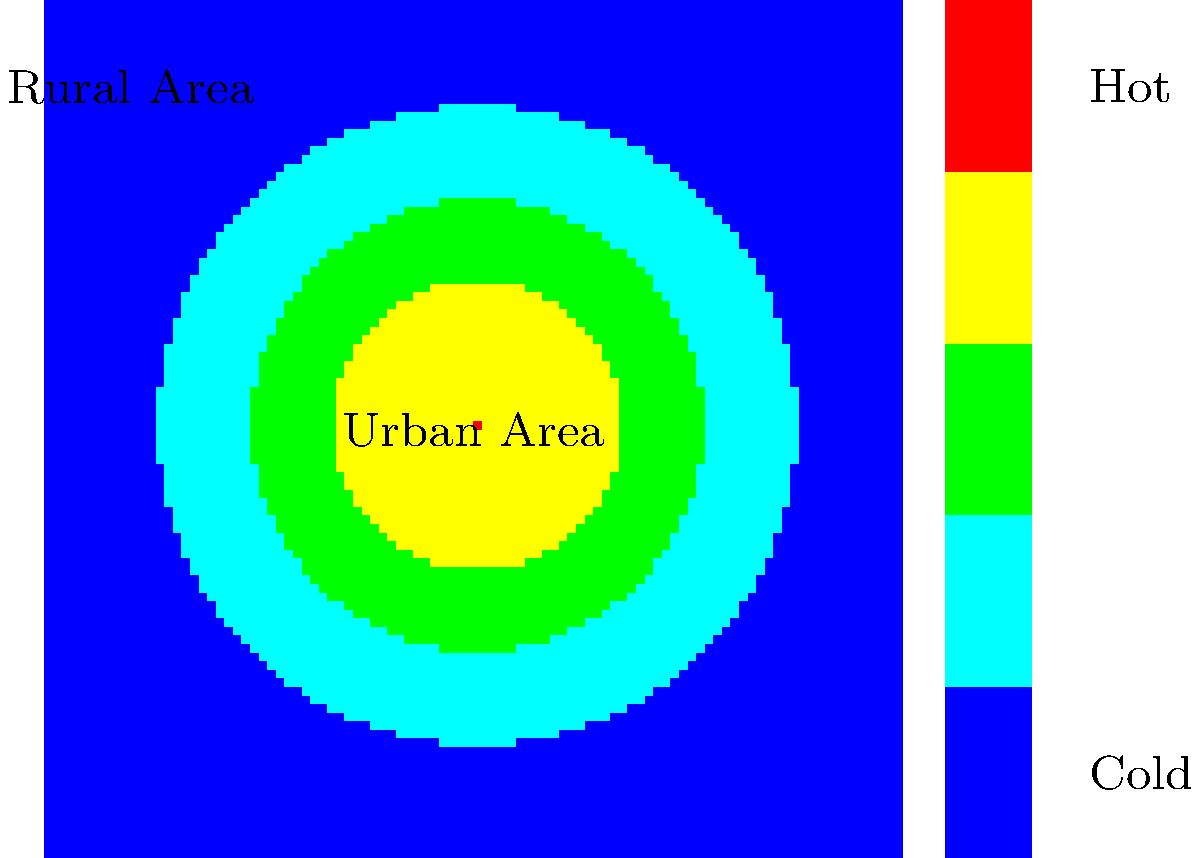The thermal imaging map shows temperature variations across an urban and rural area. What phenomenon could explain the higher temperatures observed in the center of the map, and how might this relate to local weather patterns rather than global climate trends? 1. Observe the thermal map: The center of the map shows higher temperatures (red and yellow) compared to the surrounding areas (green and blue).

2. Identify the urban heat island effect: This temperature pattern is characteristic of the urban heat island (UHI) effect, where urban areas are warmer than surrounding rural areas.

3. Understand local factors:
   a) Urban materials (concrete, asphalt) absorb and retain heat more than natural surfaces.
   b) Reduced vegetation in urban areas leads to less evaporative cooling.
   c) Urban geometry (tall buildings, narrow streets) can trap heat.
   d) Anthropogenic heat sources (vehicles, air conditioning) contribute to warming.

4. Consider local weather impacts:
   a) UHIs can create local convection currents, affecting wind patterns.
   b) They may increase the likelihood of local precipitation events.
   c) UHIs can exacerbate heat waves in cities.

5. Distinguish from global climate trends:
   a) UHIs are localized phenomena, not indicative of global patterns.
   b) They result from land-use changes, not atmospheric composition changes.
   c) UHIs can exist independently of global climate trends.

6. Conclusion: The higher temperatures in the center likely represent an urban heat island, which is a local phenomenon caused by urbanization and not directly related to global climate change.
Answer: Urban heat island effect; local urbanization impacts 